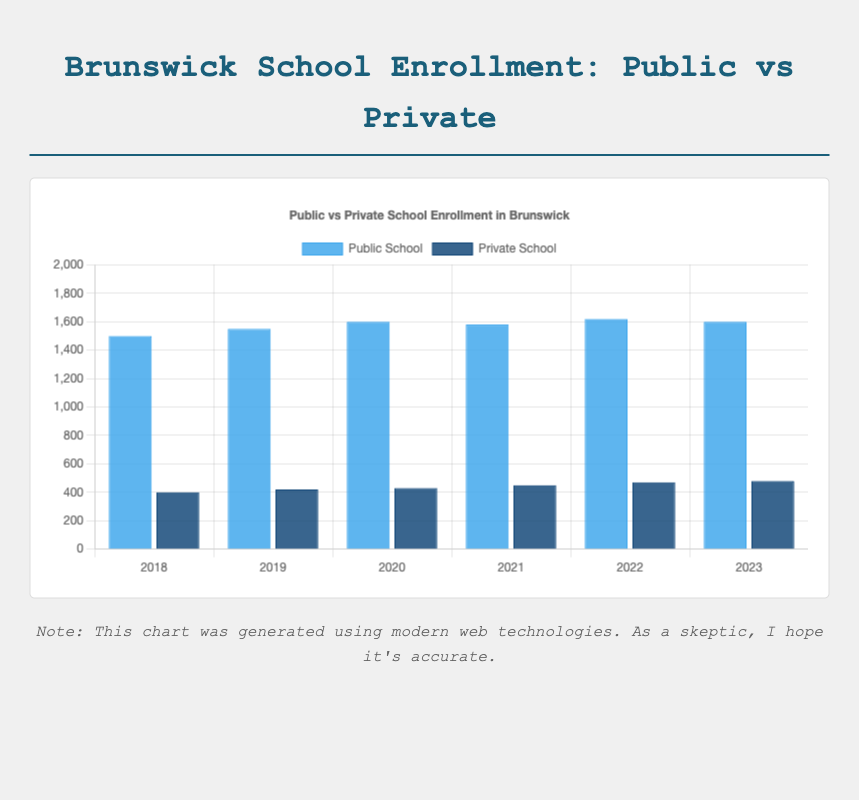What's the highest enrollment for public schools in any given year? The bars represent enrollment over the years. The tallest blue bar depicts the highest public school enrollment. The year 2022 has the highest enrollment of 1620.
Answer: 1620 Which school type saw an increase in enrollment every year from 2018 to 2023? Compare the bars each year. The blue bars for public schools fluctuate, but the dark blue bars for private schools consistently increase each year from 400 in 2018 to 480 in 2023.
Answer: Private School In which year was the difference between public and private school enrollment the smallest? Calculate the differences for each year: 
2018: 1500 - 400 = 1100
2019: 1550 - 420 = 1130
2020: 1600 - 430 = 1170
2021: 1580 - 450 = 1130
2022: 1620 - 470 = 1150
2023: 1600 - 480 = 1120.
The smallest difference is in 2018, which is 1100.
Answer: 2018 Which year had the same enrollment for public schools as another year? Check the heights of the blue bars for any matching values. 2020 and 2023 both have an enrollment of 1600.
Answer: 2020 and 2023 What’s the average private school enrollment over these years? Sum the enrollments and divide by the number of years: (400 + 420 + 430 + 450 + 470 + 480) / 6 = 2650 / 6 = 441.67
Answer: 441.67 Between 2021 and 2022, which school type had a greater increase in enrollment? Public schools: 1620 - 1580 = 40
Private schools: 470 - 450 = 20
Public schools had a greater increase.
Answer: Public School What visual cue indicates the two types of schools in the chart? The bars are colored differently, with public schools in blue and private schools in dark blue.
Answer: Different colors What's the total enrollment for both public and private schools in 2023? Add the values for both types in 2023: 1600 (public) + 480 (private) = 2080.
Answer: 2080 How many years saw a drop in public school enrollment compared to the previous year? Compare year-to-year values for public schools:
2018 to 2019: 1500 to 1550 (increase)
2019 to 2020: 1550 to 1600 (increase)
2020 to 2021: 1600 to 1580 (decrease)
2021 to 2022: 1580 to 1620 (increase)
2022 to 2023: 1620 to 1600 (decrease).
2 years saw a decrease: 2020 to 2021 and 2022 to 2023.
Answer: 2 